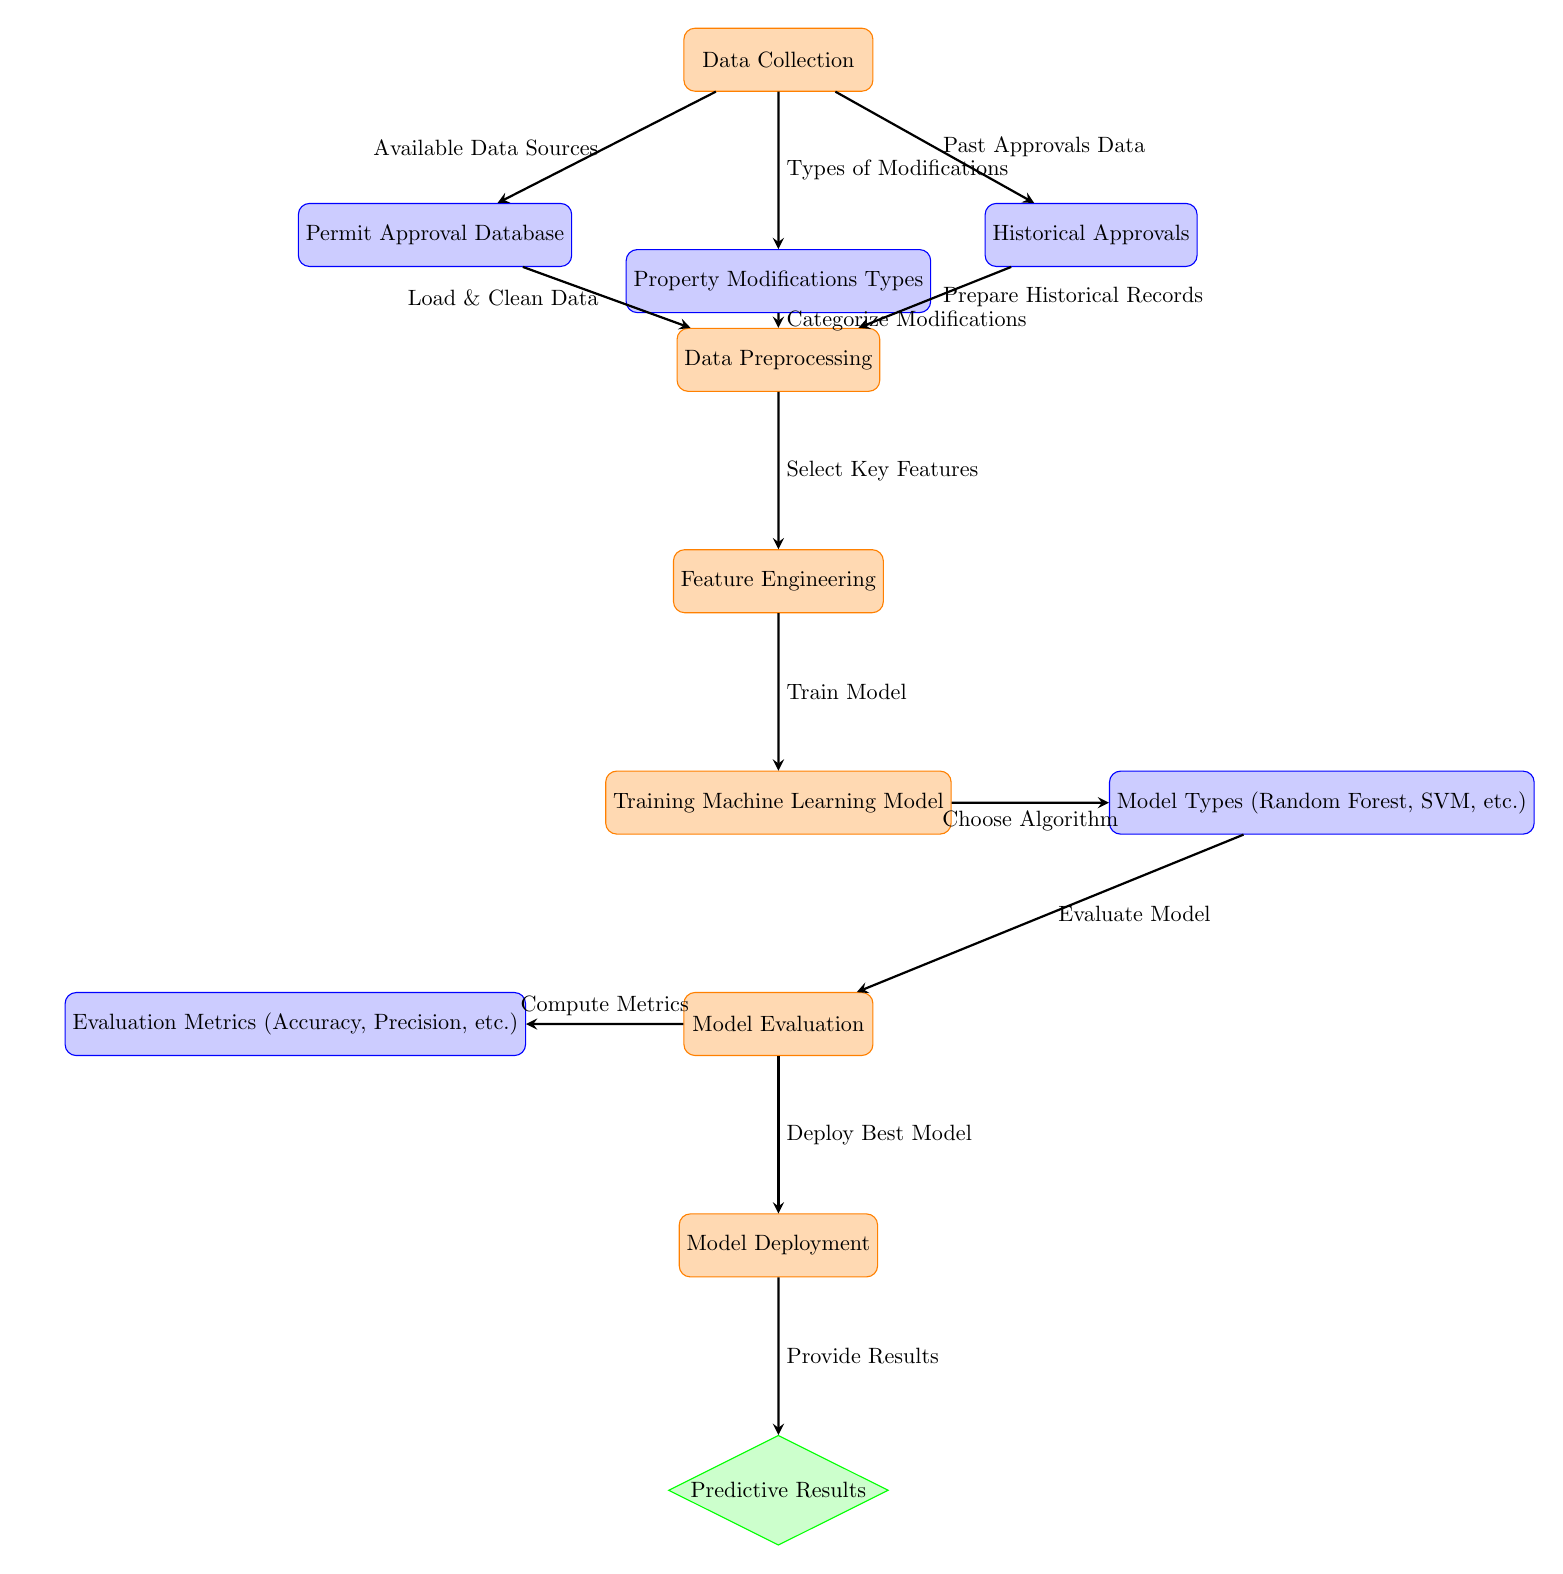What is the first step in the diagram? The first step in the diagram is "Data Collection," which indicates the starting point of the process where necessary data is gathered.
Answer: Data Collection How many types of models are indicated in the diagram? The diagram mentions "Model Types (Random Forest, SVM, etc.)" which indicates that there are multiple model types considered, but does not specify the exact number; it generally encompasses diverse types.
Answer: Multiple models What is the purpose of the "Feature Engineering" node? The "Feature Engineering" node is intended to refine the data collected by selecting key features that will be vital for training the machine learning model, ensuring effective predictions.
Answer: Select Key Features Which node comes after "Model Evaluation"? After "Model Evaluation," the next node is "Model Deployment," suggesting that once the model evaluation is complete, the best model is deployed for use.
Answer: Model Deployment What type of data is used in "Data Preprocessing"? "Data Preprocessing" uses data from three different nodes: the Permit Approval Database, Property Modifications Types, and Historical Approvals.
Answer: Permit Approval Database, Property Modifications, Historical Approvals Which evaluation metric is mentioned in the diagram? The diagram mentions "Evaluation Metrics (Accuracy, Precision, etc.)" indicating that it includes metrics related to model performance but does not specify which ones beyond these two.
Answer: Accuracy, Precision How does "Training Machine Learning Model" relate to "Feature Engineering"? The "Training Machine Learning Model" follows "Feature Engineering," indicating that once key features are selected through engineering, they are used to train the machine learning model effectively.
Answer: Training What kind of results does the diagram ultimately provide? The end result shown in the diagram is "Predictive Results," which implies that after processing through the model deployment, predictions regarding permit approval success will be made.
Answer: Predictive Results What is required for “Data Collection” according to the diagram? For "Data Collection," it is necessary to gather "Available Data Sources," "Types of Modifications," and "Past Approvals Data," each contributing to the foundational data needed for the process.
Answer: Available Data Sources, Types of Modifications, Past Approvals Data 